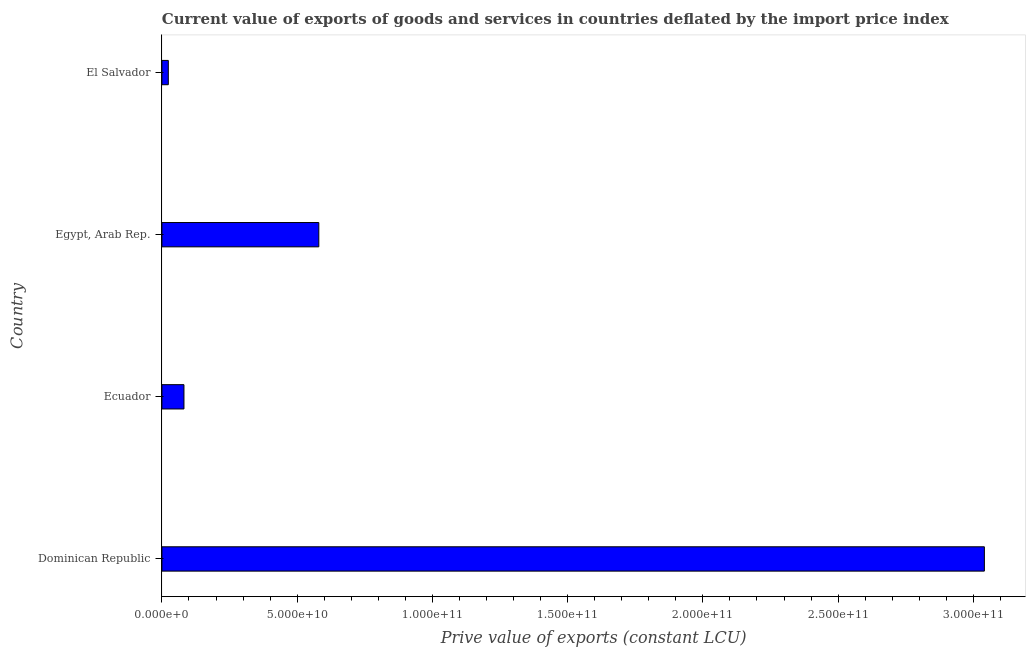Does the graph contain grids?
Make the answer very short. No. What is the title of the graph?
Provide a succinct answer. Current value of exports of goods and services in countries deflated by the import price index. What is the label or title of the X-axis?
Your answer should be very brief. Prive value of exports (constant LCU). What is the price value of exports in El Salvador?
Offer a terse response. 2.37e+09. Across all countries, what is the maximum price value of exports?
Ensure brevity in your answer.  3.04e+11. Across all countries, what is the minimum price value of exports?
Offer a terse response. 2.37e+09. In which country was the price value of exports maximum?
Your response must be concise. Dominican Republic. In which country was the price value of exports minimum?
Give a very brief answer. El Salvador. What is the sum of the price value of exports?
Offer a terse response. 3.73e+11. What is the difference between the price value of exports in Dominican Republic and Ecuador?
Ensure brevity in your answer.  2.96e+11. What is the average price value of exports per country?
Provide a short and direct response. 9.32e+1. What is the median price value of exports?
Your answer should be compact. 3.31e+1. In how many countries, is the price value of exports greater than 10000000000 LCU?
Your response must be concise. 2. What is the ratio of the price value of exports in Dominican Republic to that in Ecuador?
Provide a short and direct response. 37.3. What is the difference between the highest and the second highest price value of exports?
Keep it short and to the point. 2.46e+11. What is the difference between the highest and the lowest price value of exports?
Your answer should be very brief. 3.02e+11. In how many countries, is the price value of exports greater than the average price value of exports taken over all countries?
Offer a very short reply. 1. How many bars are there?
Provide a short and direct response. 4. Are all the bars in the graph horizontal?
Offer a terse response. Yes. What is the Prive value of exports (constant LCU) of Dominican Republic?
Make the answer very short. 3.04e+11. What is the Prive value of exports (constant LCU) in Ecuador?
Your answer should be very brief. 8.15e+09. What is the Prive value of exports (constant LCU) in Egypt, Arab Rep.?
Provide a short and direct response. 5.80e+1. What is the Prive value of exports (constant LCU) in El Salvador?
Your answer should be compact. 2.37e+09. What is the difference between the Prive value of exports (constant LCU) in Dominican Republic and Ecuador?
Offer a terse response. 2.96e+11. What is the difference between the Prive value of exports (constant LCU) in Dominican Republic and Egypt, Arab Rep.?
Your answer should be very brief. 2.46e+11. What is the difference between the Prive value of exports (constant LCU) in Dominican Republic and El Salvador?
Your response must be concise. 3.02e+11. What is the difference between the Prive value of exports (constant LCU) in Ecuador and Egypt, Arab Rep.?
Your answer should be compact. -4.99e+1. What is the difference between the Prive value of exports (constant LCU) in Ecuador and El Salvador?
Your answer should be very brief. 5.78e+09. What is the difference between the Prive value of exports (constant LCU) in Egypt, Arab Rep. and El Salvador?
Make the answer very short. 5.56e+1. What is the ratio of the Prive value of exports (constant LCU) in Dominican Republic to that in Ecuador?
Provide a short and direct response. 37.3. What is the ratio of the Prive value of exports (constant LCU) in Dominican Republic to that in Egypt, Arab Rep.?
Provide a short and direct response. 5.24. What is the ratio of the Prive value of exports (constant LCU) in Dominican Republic to that in El Salvador?
Give a very brief answer. 128.23. What is the ratio of the Prive value of exports (constant LCU) in Ecuador to that in Egypt, Arab Rep.?
Offer a terse response. 0.14. What is the ratio of the Prive value of exports (constant LCU) in Ecuador to that in El Salvador?
Ensure brevity in your answer.  3.44. What is the ratio of the Prive value of exports (constant LCU) in Egypt, Arab Rep. to that in El Salvador?
Provide a short and direct response. 24.46. 